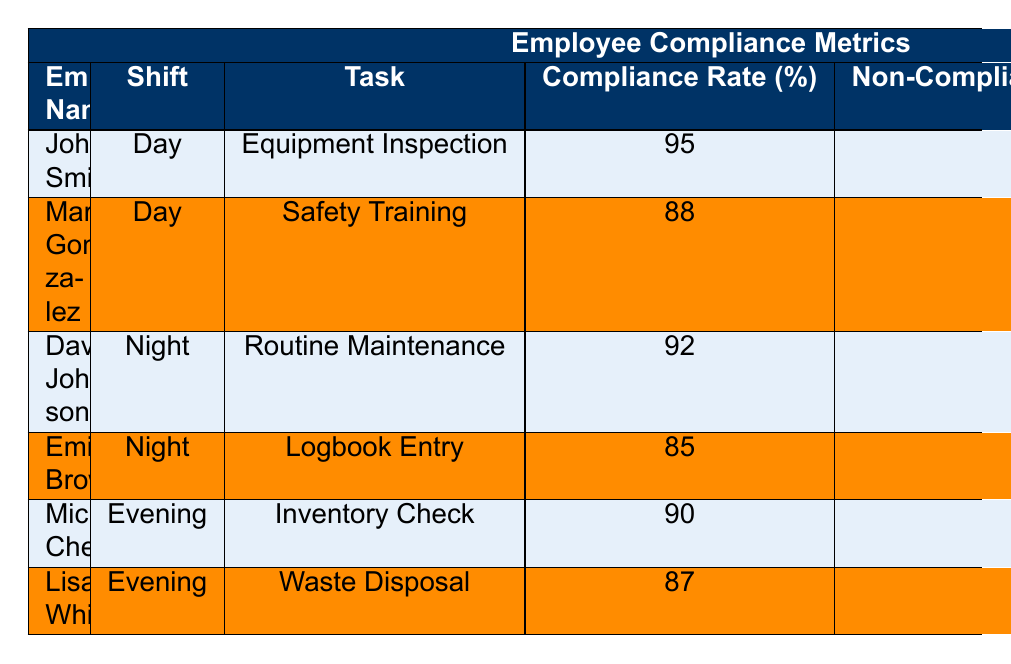What is the highest compliance rate for night shift employees? From the table, David Johnson has a compliance rate of 92% for Routine Maintenance, while Emily Brown has a compliance rate of 85% for Logbook Entry. The highest compliance rate among night shift employees is therefore 92%.
Answer: 92% How many non-compliance incidents were recorded for day shift tasks? In the day shift, John Smith has 1 non-compliance incident for Equipment Inspection and Maria Gonzalez has 2 for Safety Training. The total non-compliance incidents for day shift tasks are 1 + 2 = 3.
Answer: 3 Is it true that Lisa White had more non-compliance incidents than John Smith? Lisa White had 2 non-compliance incidents for Waste Disposal and John Smith had 1 non-compliance incident for Equipment Inspection. Since 2 is greater than 1, the statement is true.
Answer: Yes What is the average compliance rate for evening shift employees? Michael Chen has a compliance rate of 90% and Lisa White has 87%. The average compliance rate is calculated as (90 + 87) / 2 = 87.5%.
Answer: 87.5% Who had the lowest compliance rate overall? Examining the table, Emily Brown has the lowest compliance rate of 85% for Logbook Entry compared to all other employees.
Answer: Emily Brown What is the difference in non-compliance incidents between night and day shifts? For the night shift, David Johnson had 1 non-compliance incident and Emily Brown had 3, totaling 4 incidents. For the day shift, John Smith had 1 incident and Maria Gonzalez had 2, totaling 3 incidents. The difference is 4 - 3 = 1.
Answer: 1 Which employee in the table had the highest compliance rate? John Smith has the highest compliance rate of 95% for Equipment Inspection, which is greater than all other listed compliance rates.
Answer: John Smith How many total employees are listed for evening tasks? The table shows two employees for the evening shift: Michael Chen and Lisa White.
Answer: 2 